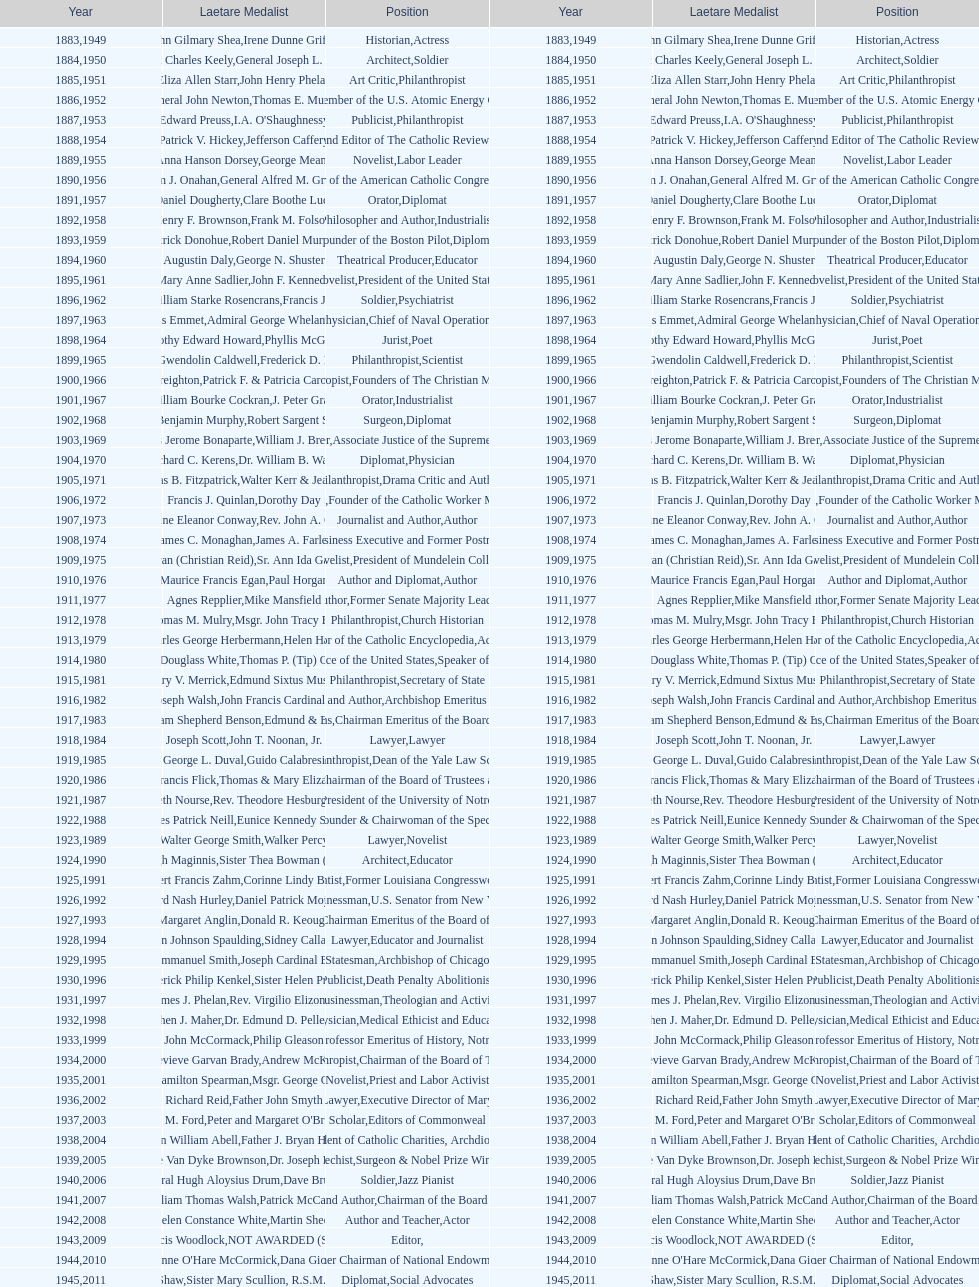How many counsel have been given the award from 1883 to 2014? 5. 